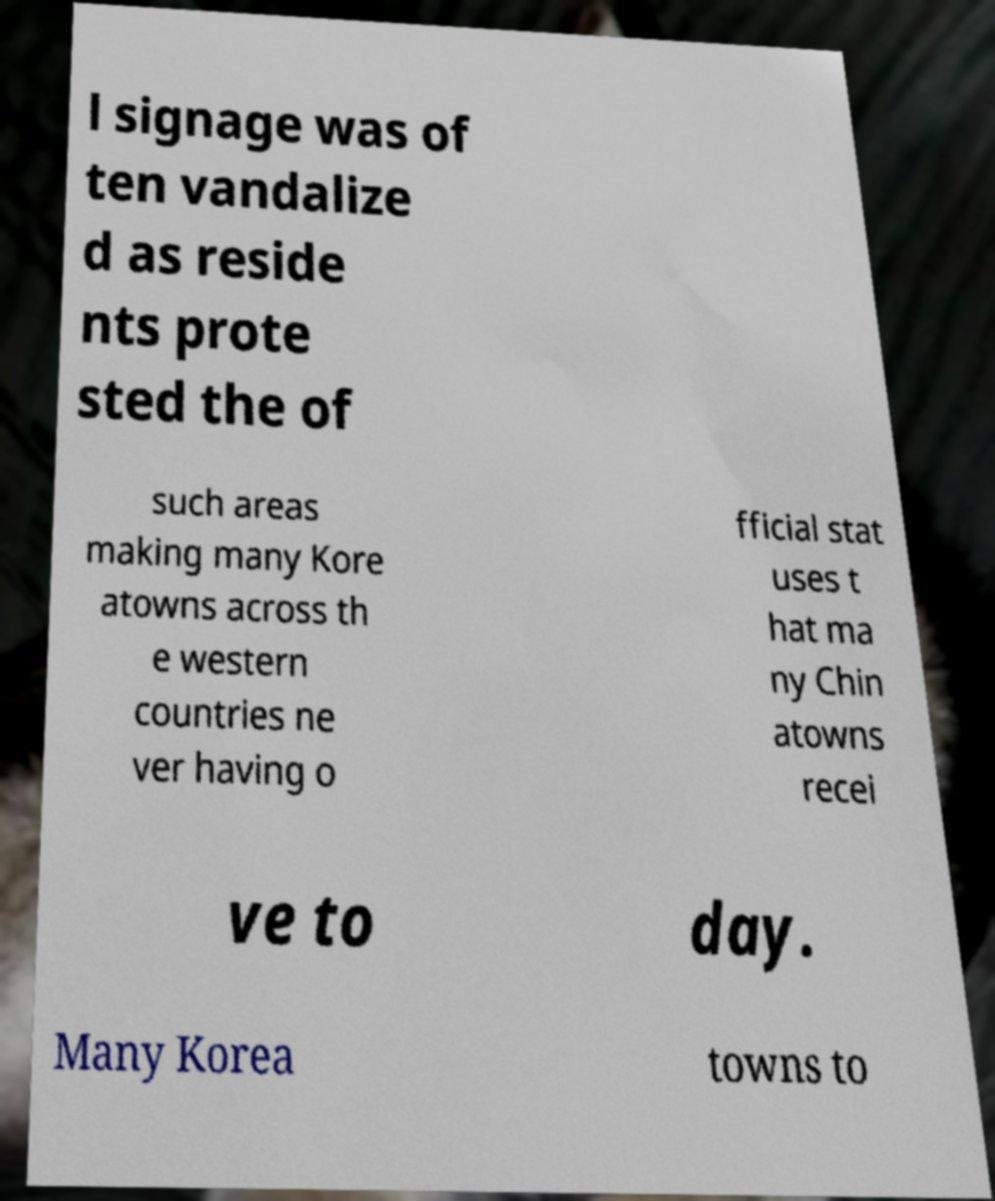I need the written content from this picture converted into text. Can you do that? l signage was of ten vandalize d as reside nts prote sted the of such areas making many Kore atowns across th e western countries ne ver having o fficial stat uses t hat ma ny Chin atowns recei ve to day. Many Korea towns to 